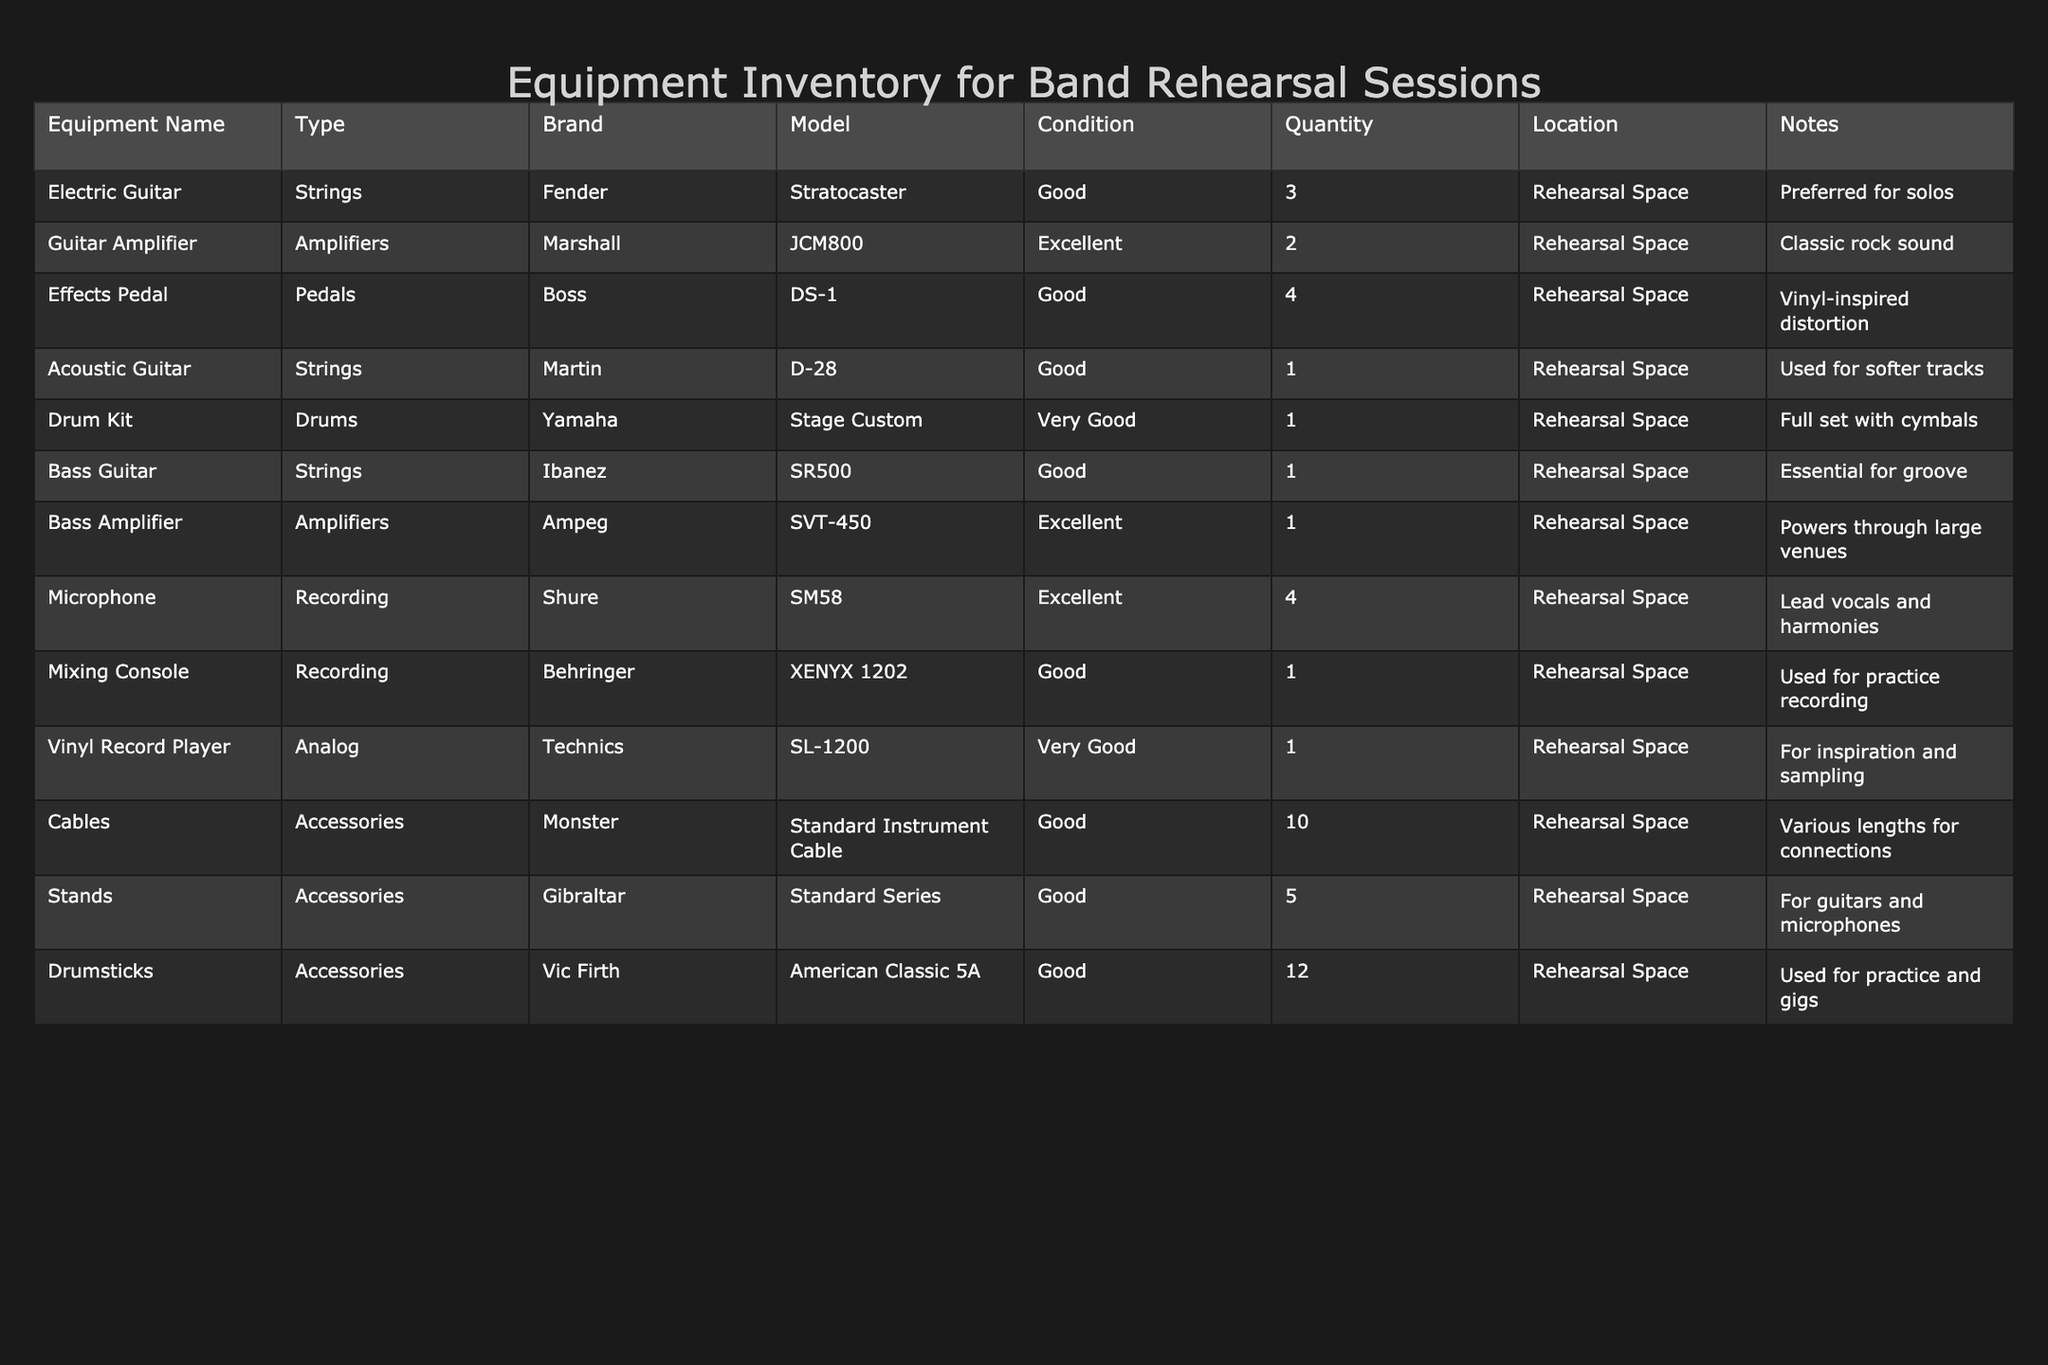What is the total number of electric guitars available? The table lists 3 electric guitars under the Quantity column for the Electric Guitar row. Therefore, adding them up gives us a total of 3.
Answer: 3 How many types of amplifiers are listed in the inventory? The table specifies two types of amplifiers: the Guitar Amplifier and the Bass Amplifier. Thus, there are two distinct types.
Answer: 2 Is the acoustic guitar in good condition? The table shows that the Acoustic Guitar is categorized as "Good" under the Condition column, confirming its state.
Answer: Yes Which brand offers a vinyl-inspired distortion effect? The Effects Pedal from the brand Boss is noted for providing a vinyl-inspired distortion effect as per the Notes column in the table.
Answer: Boss Are there more microphones or drum kits in inventory? The table indicates there are 4 microphones and only 1 drum kit. Since 4 (microphones) is greater than 1 (drum kit), this comparison shows there are more microphones.
Answer: More microphones What is the total quantity of cables available? The table lists 10 under the Quantity column for Cables. Thus, the total quantity available is simply 10.
Answer: 10 Which piece of equipment has the highest quantity listed? Reviewing the table shows that the Effects Pedal and Cables both have 4 and 10 quantities respectively. Thus, Cables with 10 is the highest quantity listed.
Answer: Cables What is the average quantity of instruments (guitars, drum kit, and bass guitar) in the rehearsal space? Adding the quantities gives us 3 (Electric Guitar) + 1 (Acoustic Guitar) + 1 (Bass Guitar) + 1 (Drum Kit) = 6. There are 4 instruments total, so averaging gives 6/4 = 1.5.
Answer: 1.5 Is there any equipment with "Excellent" condition? By looking through the Condition column, we can identify the Guitar Amplifier, Bass Amplifier, and Microphone all listed under "Excellent." Thus, this statement is true as there are multiple items in excellent condition.
Answer: Yes How many effects pedals are in good condition? The table shows a quantity of 4 for the Effects Pedal, which is in "Good" condition according to the Condition column, confirming this quantity.
Answer: 4 